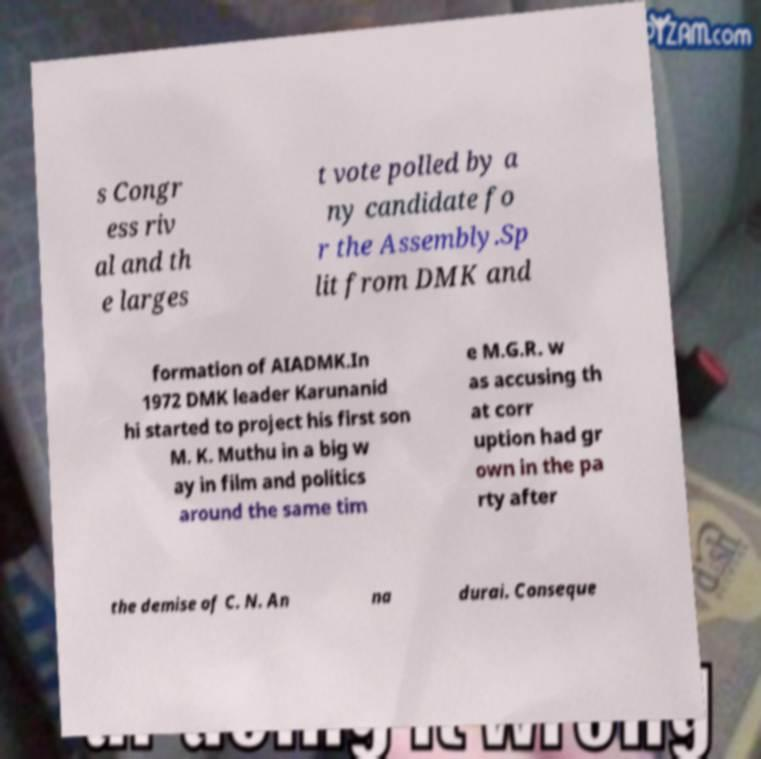Please identify and transcribe the text found in this image. s Congr ess riv al and th e larges t vote polled by a ny candidate fo r the Assembly.Sp lit from DMK and formation of AIADMK.In 1972 DMK leader Karunanid hi started to project his first son M. K. Muthu in a big w ay in film and politics around the same tim e M.G.R. w as accusing th at corr uption had gr own in the pa rty after the demise of C. N. An na durai. Conseque 